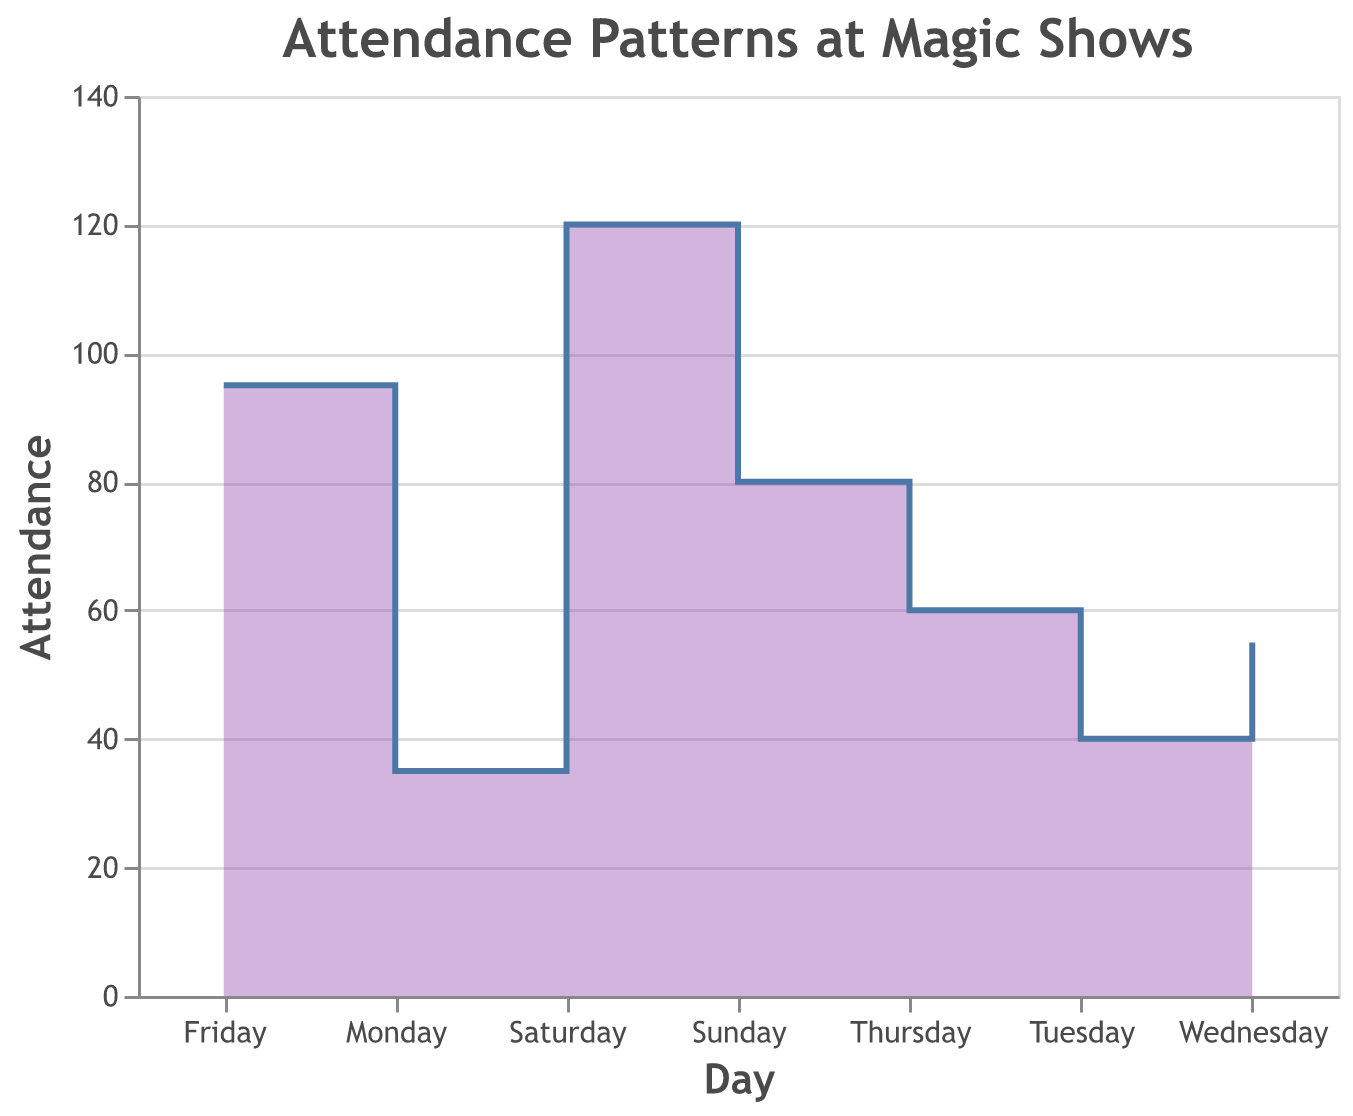What is the title of the chart? The title is located at the top of the figure, and it reads "Attendance Patterns at Magic Shows".
Answer: Attendance Patterns at Magic Shows On which day of the week is the attendance the highest? By looking at the chart, we see the highest point of the step area which is on Saturday with an attendance of 120.
Answer: Saturday How does the attendance on Sunday compare to Friday? To compare, we see Friday's attendance is 95, while Sunday's is 80 from the step area segments. Sunday has 15 fewer attendees than Friday.
Answer: Sunday's attendance is lower by 15 What is the total attendance for the entire week? Sum the attendance values for each day: 35 (Monday) + 40 (Tuesday) + 55 (Wednesday) + 60 (Thursday) + 95 (Friday) + 120 (Saturday) + 80 (Sunday) = 485.
Answer: 485 Which days see an increase in attendance compared to the previous day? By analyzing the step area chart, we find increases on Tuesday (40 > 35), Wednesday (55 > 40), Thursday (60 > 55), Friday (95 > 60), and Saturday (120 > 95). No increase from Saturday to Sunday (80 < 120).
Answer: Tuesday, Wednesday, Thursday, Friday, Saturday What is the average attendance over the weekend (Saturday and Sunday)? Calculate the average by summing the attendance on Saturday (120) and Sunday (80), then dividing by 2: (120 + 80) / 2 = 100.
Answer: 100 What is the difference in attendance between Wednesday and Monday? Wednesday's attendance is 55 and Monday's is 35. The difference is calculated as 55 - 35 = 20.
Answer: 20 What trend can be observed from Monday through Thursday? The chart shows a consistent increase in attendance each day from Monday (35) to Thursday (60).
Answer: Increasing trend How does the step pattern change from Friday to Sunday? From Friday to Saturday, the attendance increases sharply from 95 to 120, then drops to 80 on Sunday.
Answer: Increase then decrease Does the attendance ever decrease from one day to the next? If so, when? Yes, the attendance decreases from Saturday (120) to Sunday (80).
Answer: Between Saturday and Sunday 